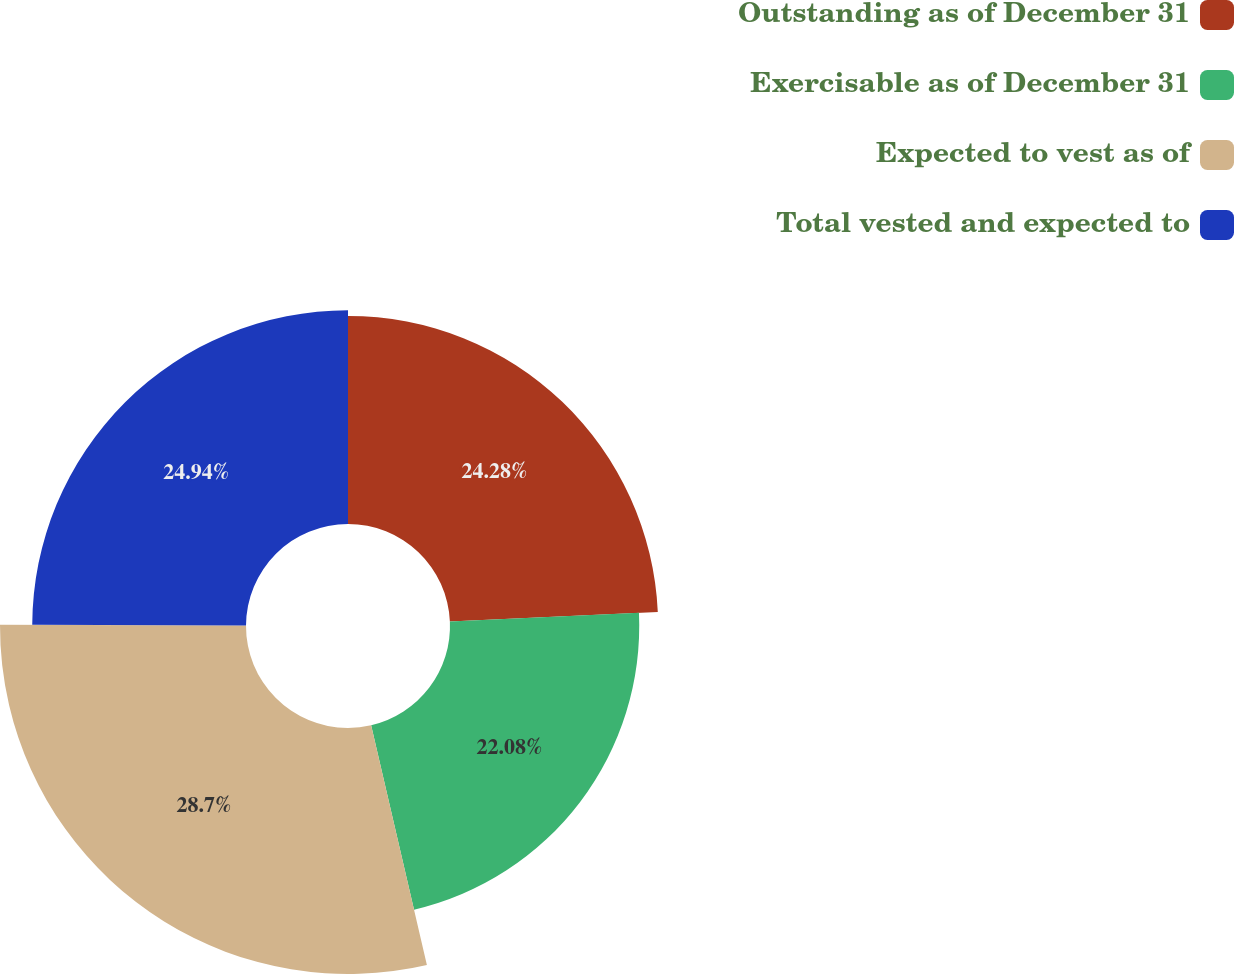Convert chart to OTSL. <chart><loc_0><loc_0><loc_500><loc_500><pie_chart><fcel>Outstanding as of December 31<fcel>Exercisable as of December 31<fcel>Expected to vest as of<fcel>Total vested and expected to<nl><fcel>24.28%<fcel>22.08%<fcel>28.7%<fcel>24.94%<nl></chart> 